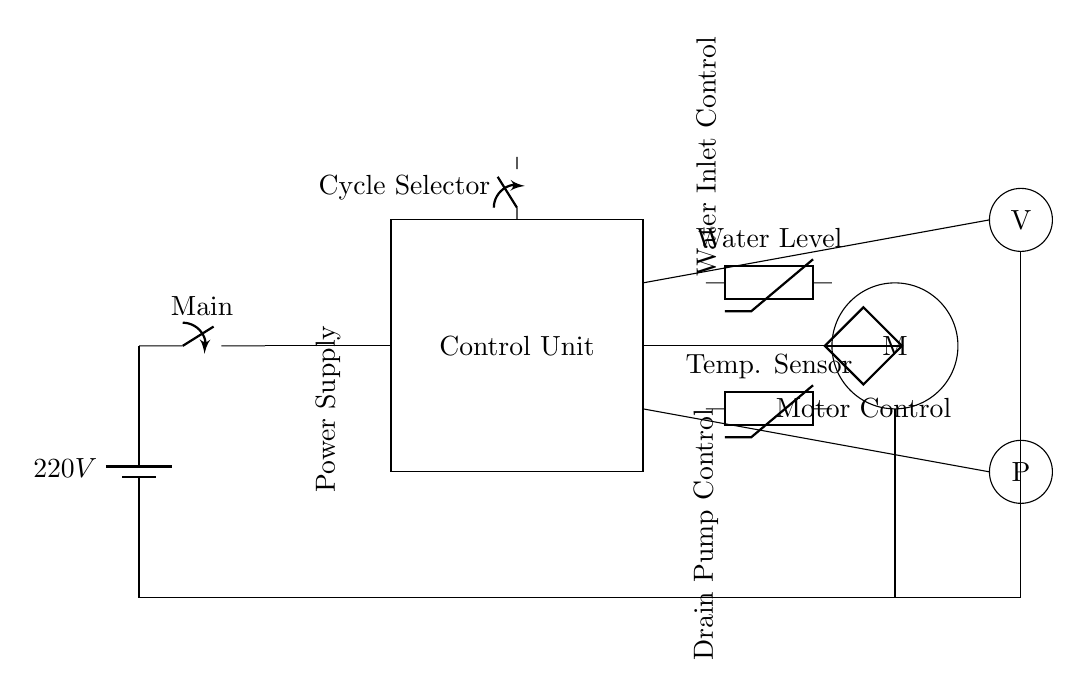What is the voltage in this circuit? The voltage of the circuit is 220V, which is indicated near the battery symbol at the start of the circuit.
Answer: 220V What is the purpose of the control unit? The control unit is responsible for managing the different functions of the washing machine, including selecting wash cycles and controlling the motor, water level, and temperature. This is indicated by its designation in the circuit.
Answer: Control What component controls the water intake? The valve (V) controls the water intake, as shown in the circuit, where it is connected to the water inlet control section.
Answer: Valve How many thermistors are present in the circuit? There are two thermistors in the circuit, one representing the water level and the other representing the temperature, which are both clearly labeled in the circuit diagram.
Answer: Two What is the function of the motor in this circuit? The motor (M) is responsible for driving the mechanical components of the washing machine during various wash cycles. Its operational control is symbolized by the connection to the controlled voltage source for motor control.
Answer: Motor Which component is responsible for pumping out water? The drain pump (P) is responsible for pumping out water, as indicated in the circuit where it is connected to the drain control section.
Answer: Pump 